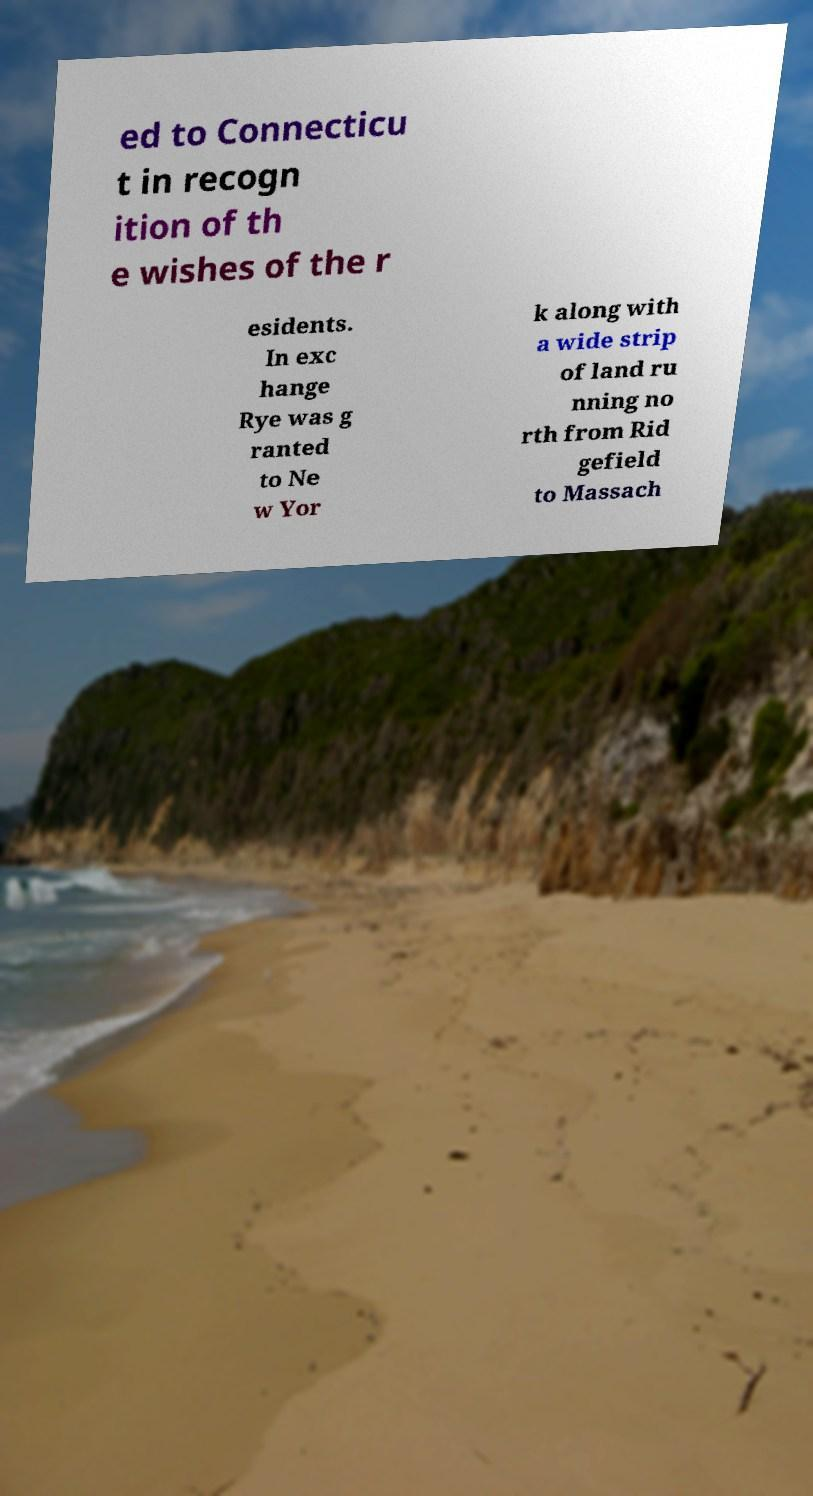Could you extract and type out the text from this image? ed to Connecticu t in recogn ition of th e wishes of the r esidents. In exc hange Rye was g ranted to Ne w Yor k along with a wide strip of land ru nning no rth from Rid gefield to Massach 